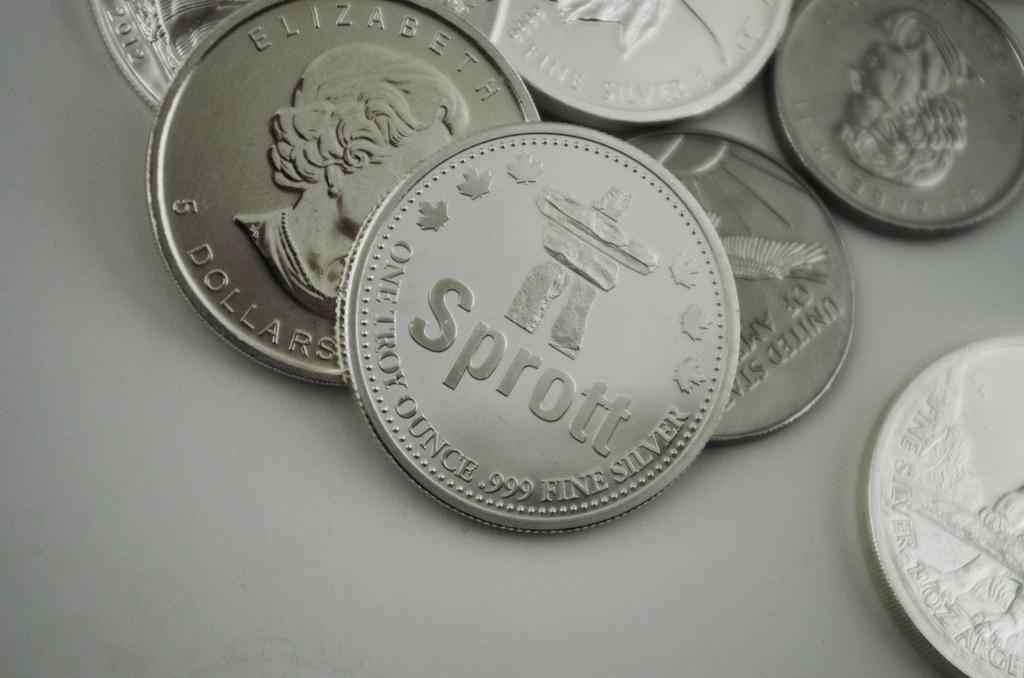<image>
Describe the image concisely. A lot of coins on a table and one with the word Sprott on it. 